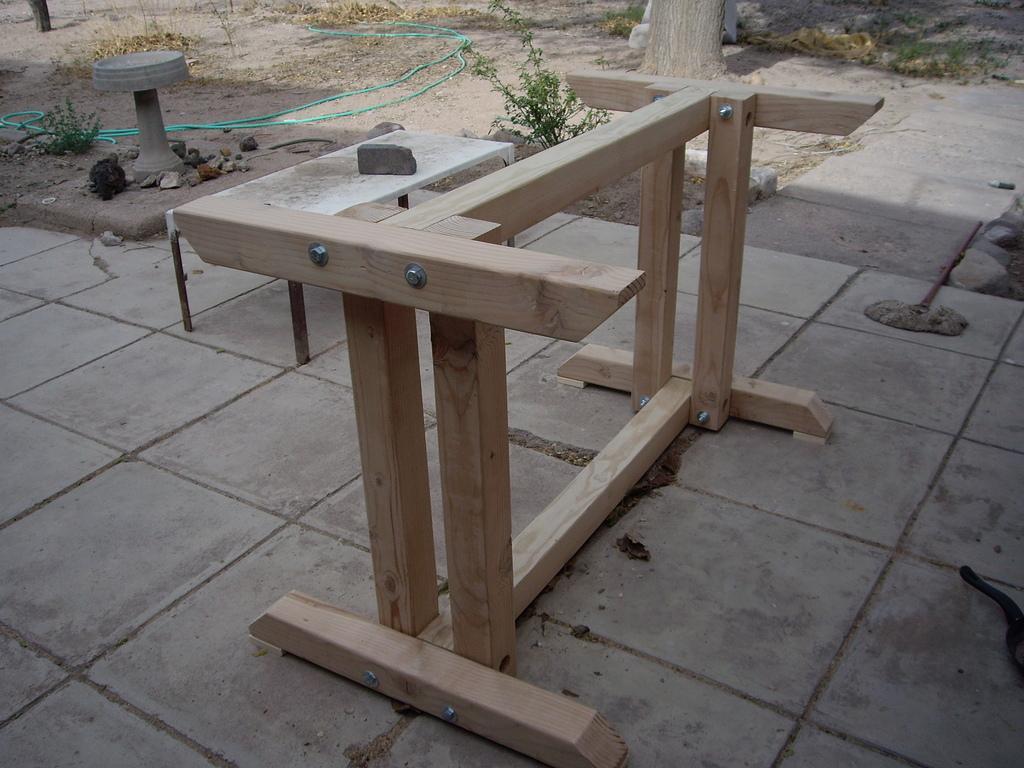Describe this image in one or two sentences. In this image there is a wooden stand and we can see a pipe. There are plants and we can see a stone placed on the stand. In the background there is a tree. 